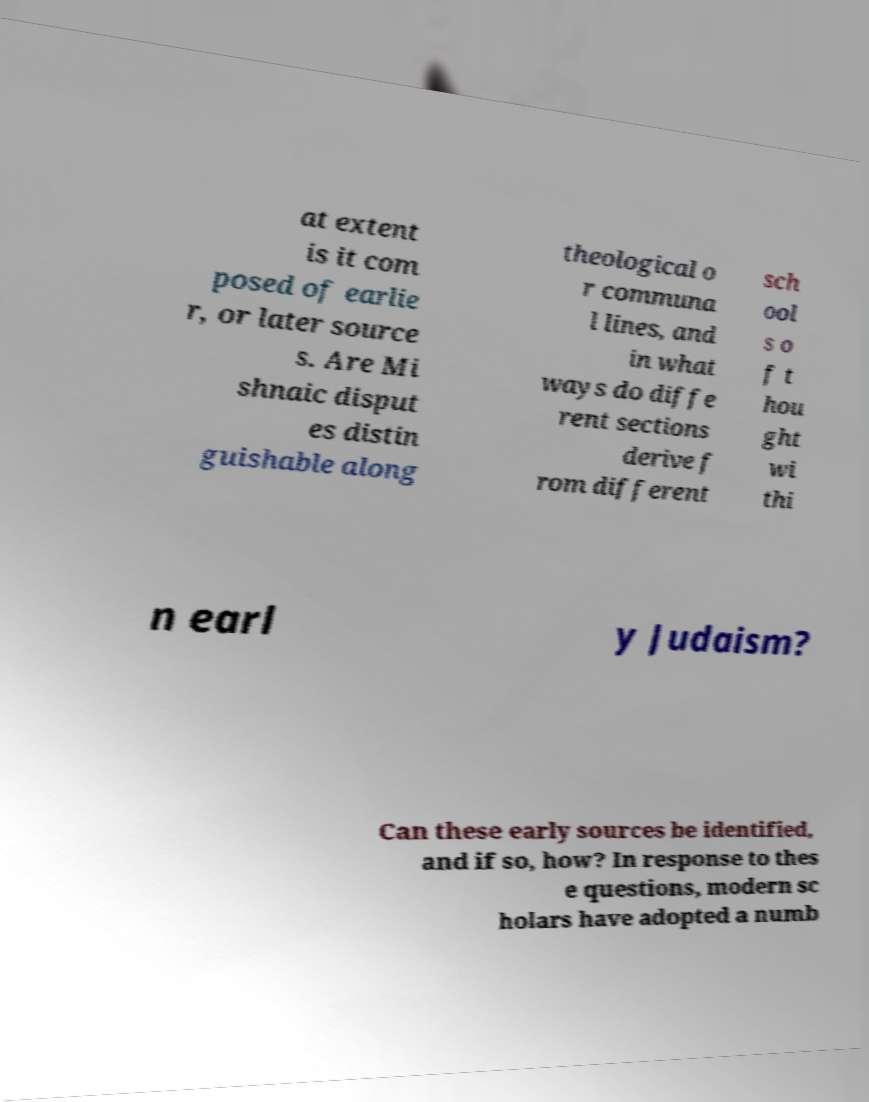What messages or text are displayed in this image? I need them in a readable, typed format. at extent is it com posed of earlie r, or later source s. Are Mi shnaic disput es distin guishable along theological o r communa l lines, and in what ways do diffe rent sections derive f rom different sch ool s o f t hou ght wi thi n earl y Judaism? Can these early sources be identified, and if so, how? In response to thes e questions, modern sc holars have adopted a numb 